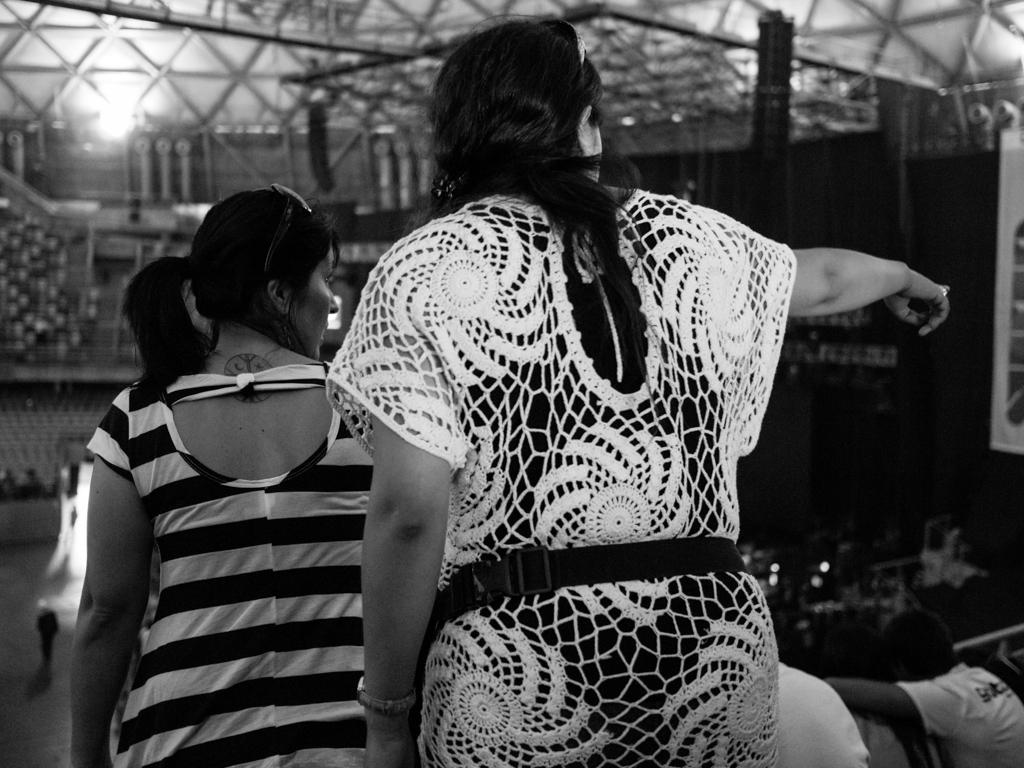What is the color scheme of the image? The image is black and white. What can be seen in the image? There are people in the image. What is visible in the background of the image? There is light visible in the background of the image. What objects are present in the image? There are rods present in the image. Can you tell me how many basketballs are being used by the people in the image? There are no basketballs present in the image; it is a black and white image with people and rods. Are there any beds visible in the image? There are no beds present in the image; it features people, rods, and light in a black and white setting. 